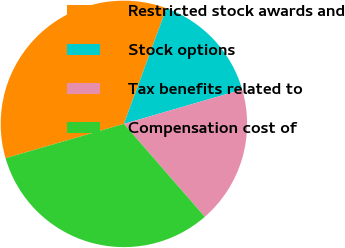Convert chart. <chart><loc_0><loc_0><loc_500><loc_500><pie_chart><fcel>Restricted stock awards and<fcel>Stock options<fcel>Tax benefits related to<fcel>Compensation cost of<nl><fcel>35.11%<fcel>14.89%<fcel>18.09%<fcel>31.91%<nl></chart> 